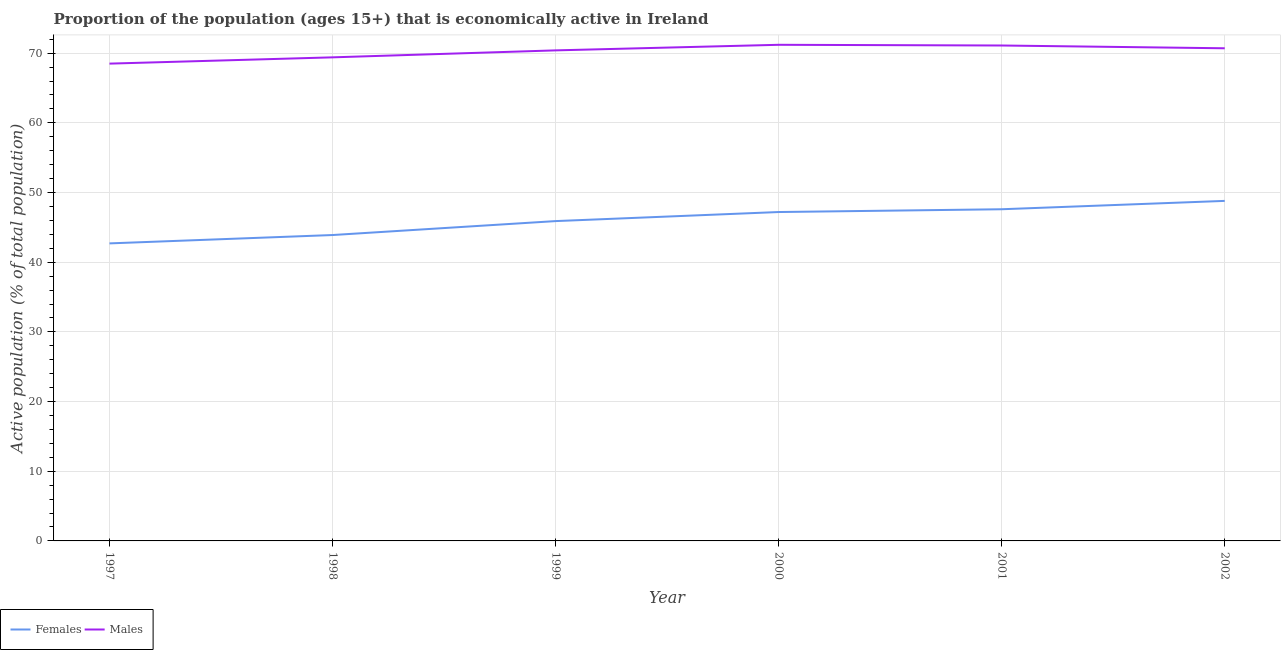How many different coloured lines are there?
Make the answer very short. 2. Does the line corresponding to percentage of economically active female population intersect with the line corresponding to percentage of economically active male population?
Keep it short and to the point. No. What is the percentage of economically active female population in 2001?
Your answer should be compact. 47.6. Across all years, what is the maximum percentage of economically active female population?
Your answer should be compact. 48.8. Across all years, what is the minimum percentage of economically active male population?
Ensure brevity in your answer.  68.5. In which year was the percentage of economically active female population maximum?
Your answer should be compact. 2002. In which year was the percentage of economically active female population minimum?
Keep it short and to the point. 1997. What is the total percentage of economically active male population in the graph?
Offer a very short reply. 421.3. What is the difference between the percentage of economically active female population in 1997 and that in 2002?
Your answer should be compact. -6.1. What is the difference between the percentage of economically active male population in 1998 and the percentage of economically active female population in 2000?
Give a very brief answer. 22.2. What is the average percentage of economically active male population per year?
Your answer should be compact. 70.22. In the year 1998, what is the difference between the percentage of economically active female population and percentage of economically active male population?
Offer a terse response. -25.5. In how many years, is the percentage of economically active male population greater than 28 %?
Give a very brief answer. 6. What is the ratio of the percentage of economically active male population in 2001 to that in 2002?
Your answer should be very brief. 1.01. Is the difference between the percentage of economically active female population in 1999 and 2002 greater than the difference between the percentage of economically active male population in 1999 and 2002?
Provide a succinct answer. No. What is the difference between the highest and the second highest percentage of economically active female population?
Your answer should be very brief. 1.2. What is the difference between the highest and the lowest percentage of economically active female population?
Your answer should be compact. 6.1. Does the percentage of economically active female population monotonically increase over the years?
Provide a succinct answer. Yes. Is the percentage of economically active male population strictly greater than the percentage of economically active female population over the years?
Make the answer very short. Yes. Is the percentage of economically active male population strictly less than the percentage of economically active female population over the years?
Your answer should be very brief. No. How many years are there in the graph?
Keep it short and to the point. 6. Does the graph contain any zero values?
Provide a short and direct response. No. How many legend labels are there?
Keep it short and to the point. 2. How are the legend labels stacked?
Provide a short and direct response. Horizontal. What is the title of the graph?
Provide a succinct answer. Proportion of the population (ages 15+) that is economically active in Ireland. What is the label or title of the Y-axis?
Give a very brief answer. Active population (% of total population). What is the Active population (% of total population) of Females in 1997?
Your response must be concise. 42.7. What is the Active population (% of total population) in Males in 1997?
Your answer should be very brief. 68.5. What is the Active population (% of total population) in Females in 1998?
Your response must be concise. 43.9. What is the Active population (% of total population) in Males in 1998?
Make the answer very short. 69.4. What is the Active population (% of total population) in Females in 1999?
Give a very brief answer. 45.9. What is the Active population (% of total population) of Males in 1999?
Provide a succinct answer. 70.4. What is the Active population (% of total population) of Females in 2000?
Make the answer very short. 47.2. What is the Active population (% of total population) in Males in 2000?
Give a very brief answer. 71.2. What is the Active population (% of total population) in Females in 2001?
Keep it short and to the point. 47.6. What is the Active population (% of total population) of Males in 2001?
Offer a terse response. 71.1. What is the Active population (% of total population) of Females in 2002?
Ensure brevity in your answer.  48.8. What is the Active population (% of total population) of Males in 2002?
Keep it short and to the point. 70.7. Across all years, what is the maximum Active population (% of total population) in Females?
Offer a terse response. 48.8. Across all years, what is the maximum Active population (% of total population) of Males?
Offer a very short reply. 71.2. Across all years, what is the minimum Active population (% of total population) of Females?
Provide a short and direct response. 42.7. Across all years, what is the minimum Active population (% of total population) in Males?
Your response must be concise. 68.5. What is the total Active population (% of total population) in Females in the graph?
Offer a very short reply. 276.1. What is the total Active population (% of total population) of Males in the graph?
Provide a short and direct response. 421.3. What is the difference between the Active population (% of total population) in Females in 1997 and that in 1998?
Your answer should be compact. -1.2. What is the difference between the Active population (% of total population) in Males in 1997 and that in 1998?
Ensure brevity in your answer.  -0.9. What is the difference between the Active population (% of total population) of Females in 1997 and that in 1999?
Your response must be concise. -3.2. What is the difference between the Active population (% of total population) in Females in 1997 and that in 2000?
Offer a very short reply. -4.5. What is the difference between the Active population (% of total population) of Females in 1997 and that in 2001?
Offer a very short reply. -4.9. What is the difference between the Active population (% of total population) in Females in 1997 and that in 2002?
Your answer should be very brief. -6.1. What is the difference between the Active population (% of total population) of Males in 1998 and that in 2000?
Give a very brief answer. -1.8. What is the difference between the Active population (% of total population) in Females in 1998 and that in 2001?
Offer a very short reply. -3.7. What is the difference between the Active population (% of total population) of Males in 1998 and that in 2001?
Give a very brief answer. -1.7. What is the difference between the Active population (% of total population) of Females in 1998 and that in 2002?
Your answer should be compact. -4.9. What is the difference between the Active population (% of total population) in Males in 1998 and that in 2002?
Make the answer very short. -1.3. What is the difference between the Active population (% of total population) of Females in 1999 and that in 2001?
Offer a very short reply. -1.7. What is the difference between the Active population (% of total population) of Males in 1999 and that in 2001?
Your answer should be compact. -0.7. What is the difference between the Active population (% of total population) of Females in 1999 and that in 2002?
Your answer should be very brief. -2.9. What is the difference between the Active population (% of total population) in Males in 2000 and that in 2001?
Provide a short and direct response. 0.1. What is the difference between the Active population (% of total population) of Females in 2000 and that in 2002?
Keep it short and to the point. -1.6. What is the difference between the Active population (% of total population) in Females in 2001 and that in 2002?
Your response must be concise. -1.2. What is the difference between the Active population (% of total population) of Females in 1997 and the Active population (% of total population) of Males in 1998?
Your answer should be very brief. -26.7. What is the difference between the Active population (% of total population) in Females in 1997 and the Active population (% of total population) in Males in 1999?
Give a very brief answer. -27.7. What is the difference between the Active population (% of total population) in Females in 1997 and the Active population (% of total population) in Males in 2000?
Ensure brevity in your answer.  -28.5. What is the difference between the Active population (% of total population) in Females in 1997 and the Active population (% of total population) in Males in 2001?
Your response must be concise. -28.4. What is the difference between the Active population (% of total population) of Females in 1997 and the Active population (% of total population) of Males in 2002?
Make the answer very short. -28. What is the difference between the Active population (% of total population) of Females in 1998 and the Active population (% of total population) of Males in 1999?
Your answer should be very brief. -26.5. What is the difference between the Active population (% of total population) of Females in 1998 and the Active population (% of total population) of Males in 2000?
Provide a succinct answer. -27.3. What is the difference between the Active population (% of total population) of Females in 1998 and the Active population (% of total population) of Males in 2001?
Give a very brief answer. -27.2. What is the difference between the Active population (% of total population) of Females in 1998 and the Active population (% of total population) of Males in 2002?
Your response must be concise. -26.8. What is the difference between the Active population (% of total population) in Females in 1999 and the Active population (% of total population) in Males in 2000?
Keep it short and to the point. -25.3. What is the difference between the Active population (% of total population) in Females in 1999 and the Active population (% of total population) in Males in 2001?
Offer a very short reply. -25.2. What is the difference between the Active population (% of total population) of Females in 1999 and the Active population (% of total population) of Males in 2002?
Provide a succinct answer. -24.8. What is the difference between the Active population (% of total population) of Females in 2000 and the Active population (% of total population) of Males in 2001?
Your answer should be compact. -23.9. What is the difference between the Active population (% of total population) in Females in 2000 and the Active population (% of total population) in Males in 2002?
Your response must be concise. -23.5. What is the difference between the Active population (% of total population) in Females in 2001 and the Active population (% of total population) in Males in 2002?
Give a very brief answer. -23.1. What is the average Active population (% of total population) in Females per year?
Offer a very short reply. 46.02. What is the average Active population (% of total population) of Males per year?
Your response must be concise. 70.22. In the year 1997, what is the difference between the Active population (% of total population) in Females and Active population (% of total population) in Males?
Your response must be concise. -25.8. In the year 1998, what is the difference between the Active population (% of total population) of Females and Active population (% of total population) of Males?
Give a very brief answer. -25.5. In the year 1999, what is the difference between the Active population (% of total population) in Females and Active population (% of total population) in Males?
Ensure brevity in your answer.  -24.5. In the year 2001, what is the difference between the Active population (% of total population) in Females and Active population (% of total population) in Males?
Your answer should be very brief. -23.5. In the year 2002, what is the difference between the Active population (% of total population) in Females and Active population (% of total population) in Males?
Offer a terse response. -21.9. What is the ratio of the Active population (% of total population) in Females in 1997 to that in 1998?
Ensure brevity in your answer.  0.97. What is the ratio of the Active population (% of total population) of Males in 1997 to that in 1998?
Ensure brevity in your answer.  0.99. What is the ratio of the Active population (% of total population) in Females in 1997 to that in 1999?
Provide a short and direct response. 0.93. What is the ratio of the Active population (% of total population) in Males in 1997 to that in 1999?
Your answer should be very brief. 0.97. What is the ratio of the Active population (% of total population) in Females in 1997 to that in 2000?
Offer a terse response. 0.9. What is the ratio of the Active population (% of total population) in Males in 1997 to that in 2000?
Offer a very short reply. 0.96. What is the ratio of the Active population (% of total population) of Females in 1997 to that in 2001?
Offer a terse response. 0.9. What is the ratio of the Active population (% of total population) of Males in 1997 to that in 2001?
Your answer should be very brief. 0.96. What is the ratio of the Active population (% of total population) of Females in 1997 to that in 2002?
Your answer should be compact. 0.88. What is the ratio of the Active population (% of total population) in Males in 1997 to that in 2002?
Offer a very short reply. 0.97. What is the ratio of the Active population (% of total population) of Females in 1998 to that in 1999?
Your answer should be very brief. 0.96. What is the ratio of the Active population (% of total population) of Males in 1998 to that in 1999?
Give a very brief answer. 0.99. What is the ratio of the Active population (% of total population) of Females in 1998 to that in 2000?
Ensure brevity in your answer.  0.93. What is the ratio of the Active population (% of total population) in Males in 1998 to that in 2000?
Ensure brevity in your answer.  0.97. What is the ratio of the Active population (% of total population) of Females in 1998 to that in 2001?
Make the answer very short. 0.92. What is the ratio of the Active population (% of total population) of Males in 1998 to that in 2001?
Make the answer very short. 0.98. What is the ratio of the Active population (% of total population) in Females in 1998 to that in 2002?
Your response must be concise. 0.9. What is the ratio of the Active population (% of total population) in Males in 1998 to that in 2002?
Give a very brief answer. 0.98. What is the ratio of the Active population (% of total population) of Females in 1999 to that in 2000?
Your answer should be compact. 0.97. What is the ratio of the Active population (% of total population) of Males in 1999 to that in 2000?
Offer a terse response. 0.99. What is the ratio of the Active population (% of total population) in Females in 1999 to that in 2001?
Offer a very short reply. 0.96. What is the ratio of the Active population (% of total population) of Males in 1999 to that in 2001?
Give a very brief answer. 0.99. What is the ratio of the Active population (% of total population) in Females in 1999 to that in 2002?
Your answer should be compact. 0.94. What is the ratio of the Active population (% of total population) of Males in 2000 to that in 2001?
Make the answer very short. 1. What is the ratio of the Active population (% of total population) in Females in 2000 to that in 2002?
Provide a short and direct response. 0.97. What is the ratio of the Active population (% of total population) of Males in 2000 to that in 2002?
Your answer should be very brief. 1.01. What is the ratio of the Active population (% of total population) in Females in 2001 to that in 2002?
Give a very brief answer. 0.98. What is the difference between the highest and the second highest Active population (% of total population) of Females?
Offer a very short reply. 1.2. What is the difference between the highest and the second highest Active population (% of total population) of Males?
Provide a short and direct response. 0.1. What is the difference between the highest and the lowest Active population (% of total population) of Females?
Your answer should be compact. 6.1. 